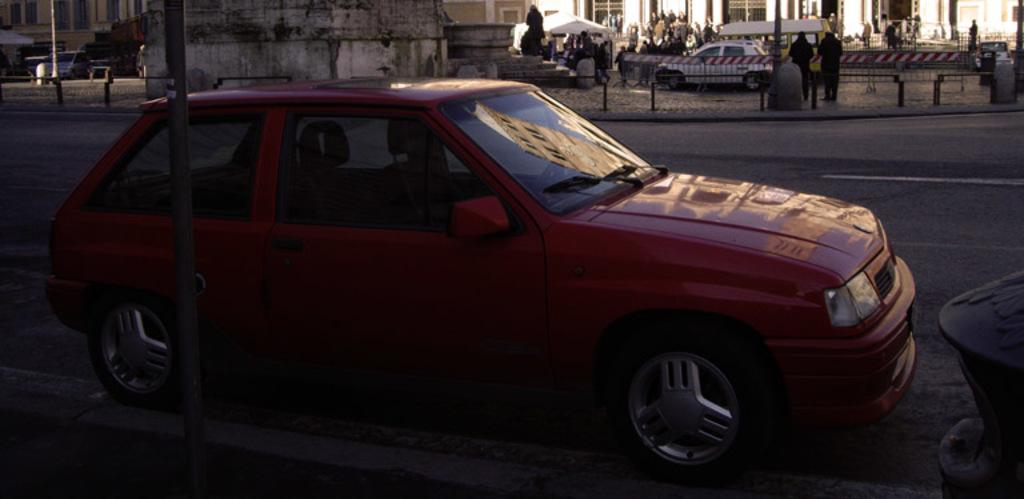What can be seen on the road in the image? There are vehicles on the road in the image. What is visible in the background of the image? In the background of the image, there are people, buildings, railings, poles, stones, and tents. Can you describe a specific object in the image? Yes, there is a statue in the image. What type of error is being corrected in the image? There is no indication of an error or correction in the image. Can you tell me the account number of the person in the image? There is no account number visible in the image. 